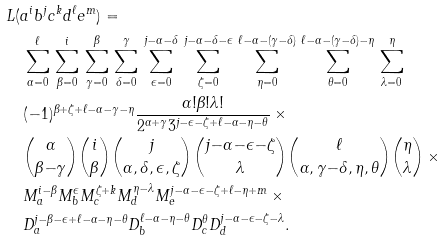<formula> <loc_0><loc_0><loc_500><loc_500>& L ( a ^ { i } b ^ { j } c ^ { k } d ^ { \ell } e ^ { m } ) = \\ & \quad \sum _ { \alpha = 0 } ^ { \ell } \, \sum _ { \beta = 0 } ^ { i } \, \sum _ { \gamma = 0 } ^ { \beta } \, \sum _ { \delta = 0 } ^ { \gamma } \, \sum _ { \epsilon = 0 } ^ { j - \alpha - \delta } \, \sum _ { \zeta = 0 } ^ { j - \alpha - \delta - \epsilon } \, \sum _ { \eta = 0 } ^ { \ell - \alpha - ( \gamma - \delta ) } \, \sum _ { \theta = 0 } ^ { \ell - \alpha - ( \gamma - \delta ) - \eta } \, \sum _ { \lambda = 0 } ^ { \eta } \\ & \quad ( - 1 ) ^ { \beta + \zeta + \ell - \alpha - \gamma - \eta } \frac { \alpha ! \beta ! \lambda ! } { 2 ^ { \alpha + \gamma } 3 ^ { j - \epsilon - \zeta + \ell - \alpha - \eta - \theta } } \, \times \\ & \quad \binom { \alpha } { \beta { - } \gamma } \binom { i } { \beta } \binom { j } { \alpha , \delta , \epsilon , \zeta } \binom { j { - } \alpha { - } \epsilon { - } \zeta } { \lambda } \binom { \ell } { \alpha , \gamma { - } \delta , \eta , \theta } \binom { \eta } { \lambda } \, \times \\ & \quad M _ { a } ^ { i - \beta } M _ { b } ^ { \epsilon } M _ { c } ^ { \zeta + k } M _ { d } ^ { \eta - \lambda } M _ { e } ^ { j - \alpha - \epsilon - \zeta + \ell - \eta + m } \, \times \\ & \quad D _ { a } ^ { j - \beta - \epsilon + \ell - \alpha - \eta - \theta } D _ { b } ^ { \ell - \alpha - \eta - \theta } D _ { c } ^ { \theta } D _ { d } ^ { j - \alpha - \epsilon - \zeta - \lambda } .</formula> 